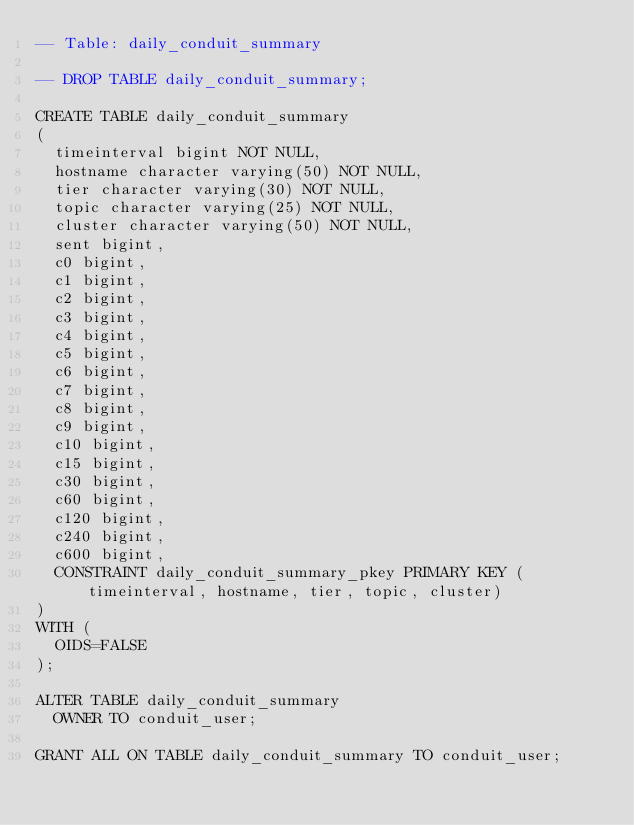Convert code to text. <code><loc_0><loc_0><loc_500><loc_500><_SQL_>-- Table: daily_conduit_summary

-- DROP TABLE daily_conduit_summary;

CREATE TABLE daily_conduit_summary
(
  timeinterval bigint NOT NULL,
  hostname character varying(50) NOT NULL,
  tier character varying(30) NOT NULL,
  topic character varying(25) NOT NULL,
  cluster character varying(50) NOT NULL,
  sent bigint,
  c0 bigint,
  c1 bigint,
  c2 bigint,
  c3 bigint,
  c4 bigint,
  c5 bigint,
  c6 bigint,
  c7 bigint,
  c8 bigint,
  c9 bigint,
  c10 bigint,
  c15 bigint,
  c30 bigint,
  c60 bigint,
  c120 bigint,
  c240 bigint,
  c600 bigint,
  CONSTRAINT daily_conduit_summary_pkey PRIMARY KEY (timeinterval, hostname, tier, topic, cluster)
)
WITH (
  OIDS=FALSE
);

ALTER TABLE daily_conduit_summary
  OWNER TO conduit_user;

GRANT ALL ON TABLE daily_conduit_summary TO conduit_user;


</code> 